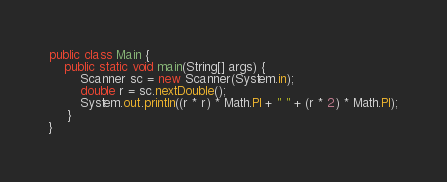<code> <loc_0><loc_0><loc_500><loc_500><_Java_>public class Main {
    public static void main(String[] args) {
        Scanner sc = new Scanner(System.in);
        double r = sc.nextDouble();
        System.out.println((r * r) * Math.PI + " " + (r * 2) * Math.PI);
     }
}
</code> 